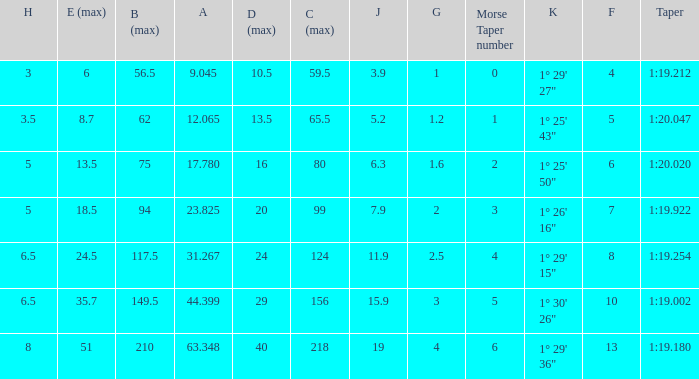04 1.0. 